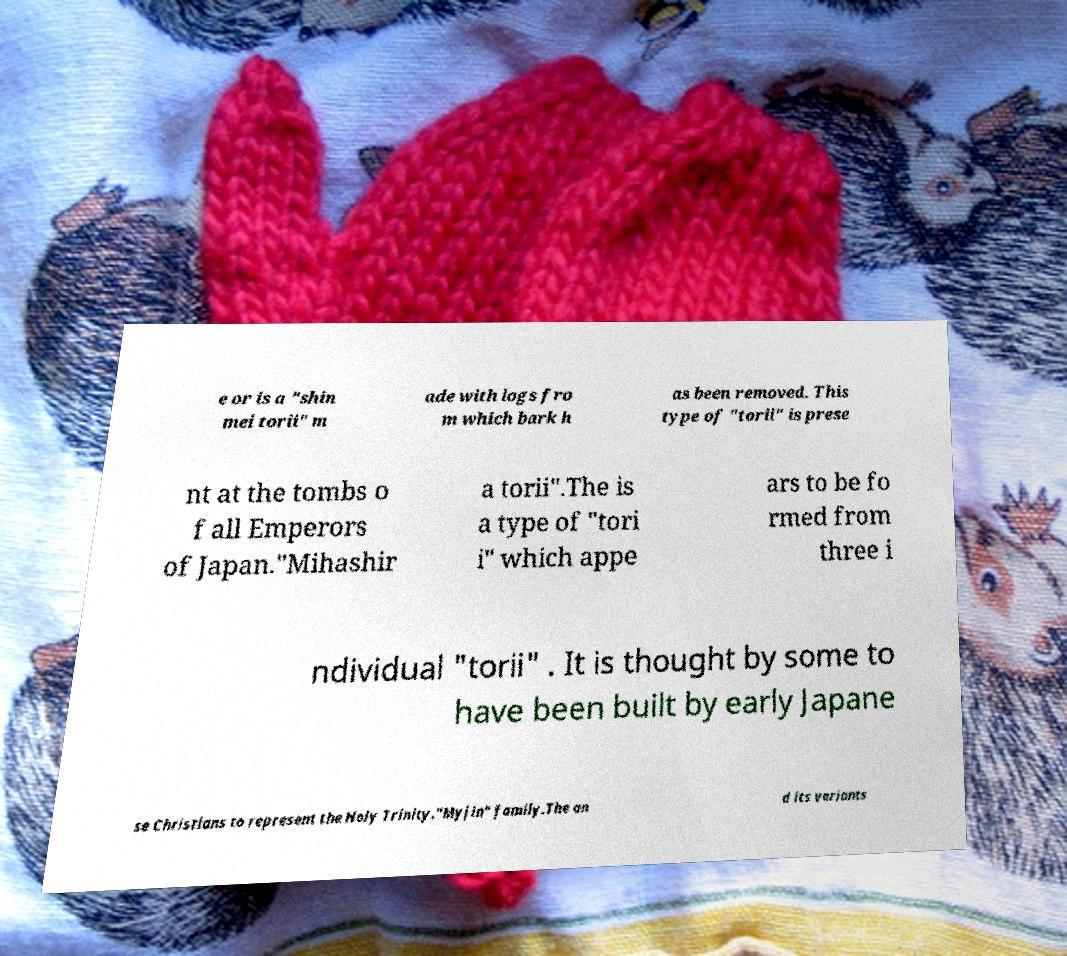I need the written content from this picture converted into text. Can you do that? e or is a "shin mei torii" m ade with logs fro m which bark h as been removed. This type of "torii" is prese nt at the tombs o f all Emperors of Japan."Mihashir a torii".The is a type of "tori i" which appe ars to be fo rmed from three i ndividual "torii" . It is thought by some to have been built by early Japane se Christians to represent the Holy Trinity."Myjin" family.The an d its variants 